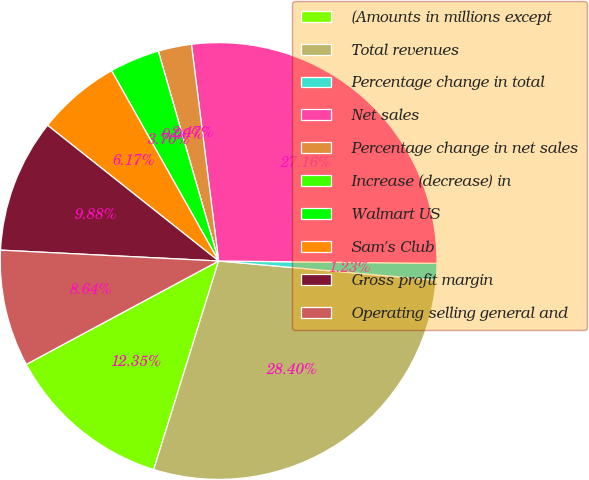Convert chart. <chart><loc_0><loc_0><loc_500><loc_500><pie_chart><fcel>(Amounts in millions except<fcel>Total revenues<fcel>Percentage change in total<fcel>Net sales<fcel>Percentage change in net sales<fcel>Increase (decrease) in<fcel>Walmart US<fcel>Sam's Club<fcel>Gross profit margin<fcel>Operating selling general and<nl><fcel>12.35%<fcel>28.4%<fcel>1.23%<fcel>27.16%<fcel>2.47%<fcel>0.0%<fcel>3.7%<fcel>6.17%<fcel>9.88%<fcel>8.64%<nl></chart> 